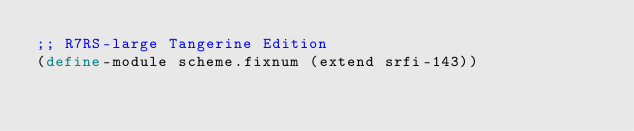Convert code to text. <code><loc_0><loc_0><loc_500><loc_500><_Scheme_>;; R7RS-large Tangerine Edition
(define-module scheme.fixnum (extend srfi-143))
</code> 